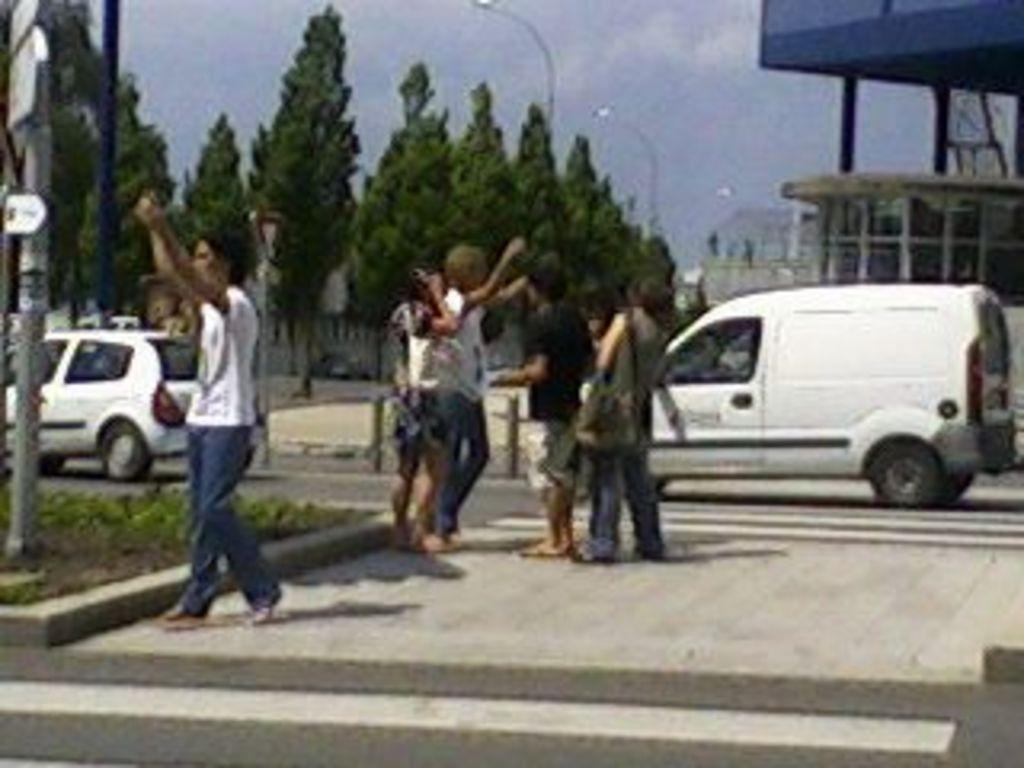Can you describe this image briefly? In this picture there are group of people. At the back there are vehicles on the road and there are buildings and trees and poles. At the top there is sky and there are clouds. At the bottom there is a road. In the foreground there is a staircase. 